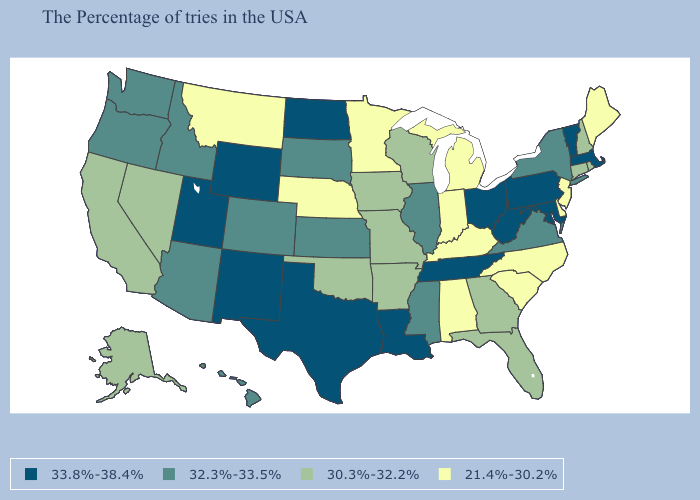What is the lowest value in the USA?
Concise answer only. 21.4%-30.2%. Among the states that border New Jersey , does New York have the lowest value?
Write a very short answer. No. Among the states that border North Dakota , which have the lowest value?
Short answer required. Minnesota, Montana. What is the value of Maryland?
Write a very short answer. 33.8%-38.4%. Among the states that border New York , does Pennsylvania have the lowest value?
Be succinct. No. How many symbols are there in the legend?
Quick response, please. 4. Does West Virginia have the lowest value in the USA?
Answer briefly. No. What is the lowest value in the Northeast?
Be succinct. 21.4%-30.2%. What is the value of Minnesota?
Give a very brief answer. 21.4%-30.2%. Name the states that have a value in the range 21.4%-30.2%?
Write a very short answer. Maine, New Jersey, Delaware, North Carolina, South Carolina, Michigan, Kentucky, Indiana, Alabama, Minnesota, Nebraska, Montana. Among the states that border Indiana , does Illinois have the highest value?
Quick response, please. No. What is the value of Texas?
Keep it brief. 33.8%-38.4%. Does Arizona have the lowest value in the West?
Keep it brief. No. What is the lowest value in the USA?
Short answer required. 21.4%-30.2%. Does Colorado have a lower value than Wyoming?
Write a very short answer. Yes. 